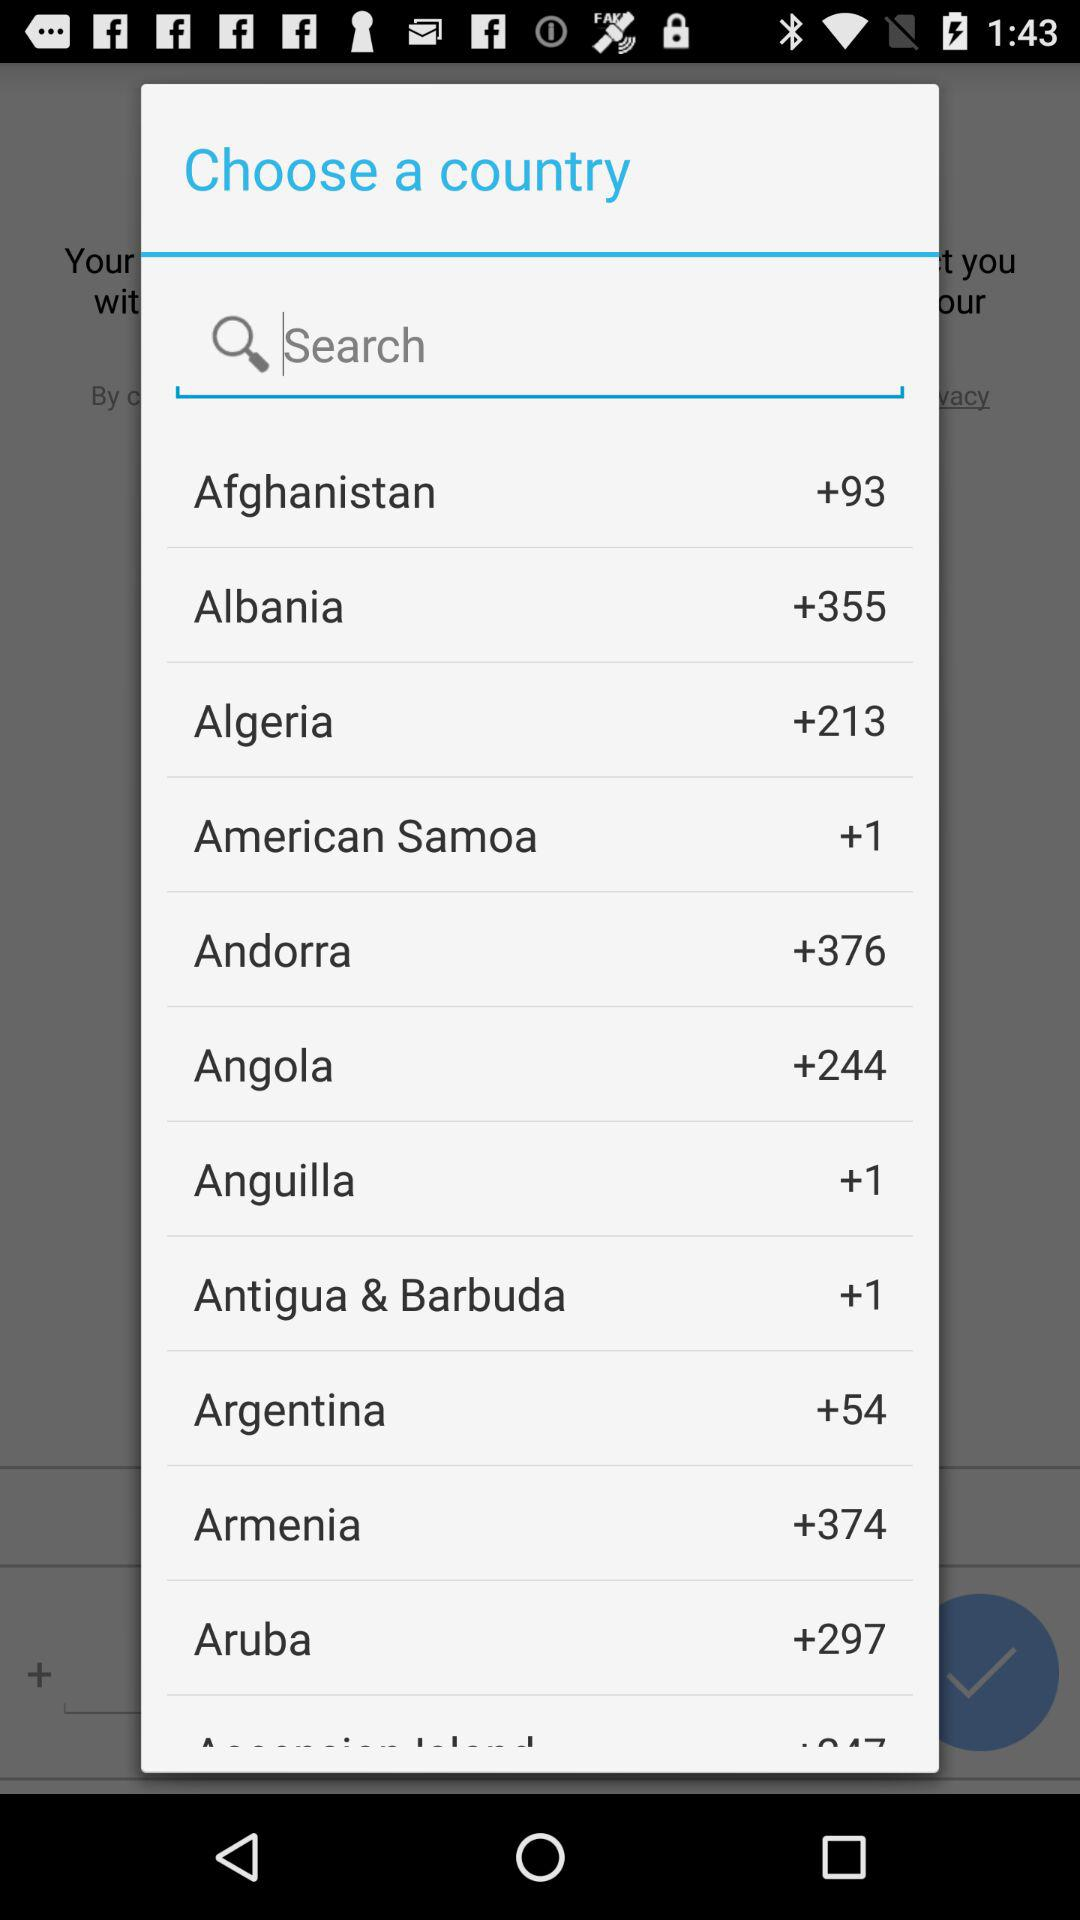Which country code is selected?
When the provided information is insufficient, respond with <no answer>. <no answer> 